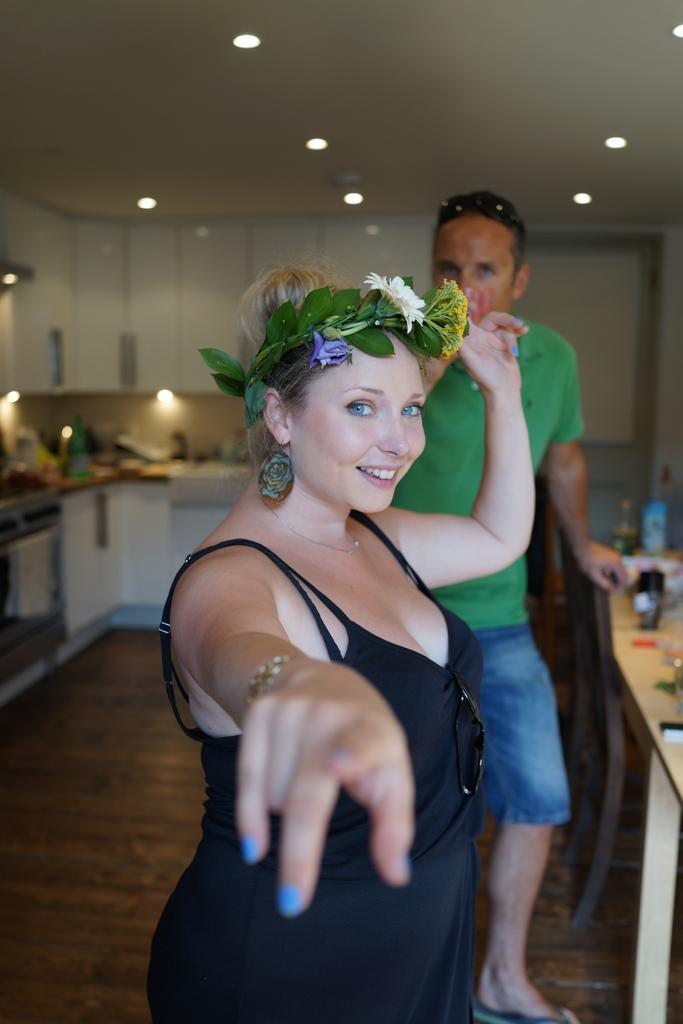How many people are present in the image? There is a woman and a man in the image, so there are two people present. What is the woman doing in the image? The woman is smiling in the image. What type of furniture can be seen in the image? There are tables and cupboards in the image. What items can be found on the tables? There are bottles on the tables. What is the purpose of the towel in the image? The towel might be used for cleaning or drying purposes. What can be seen in the background of the image? There are lights and a ceiling in the background of the image. Can you tell me how many waves are visible in the image? There are no waves present in the image; it features a woman, a man, and various objects in an indoor setting. What type of pencil is being used by the team in the image? There is no team or pencil present in the image. 